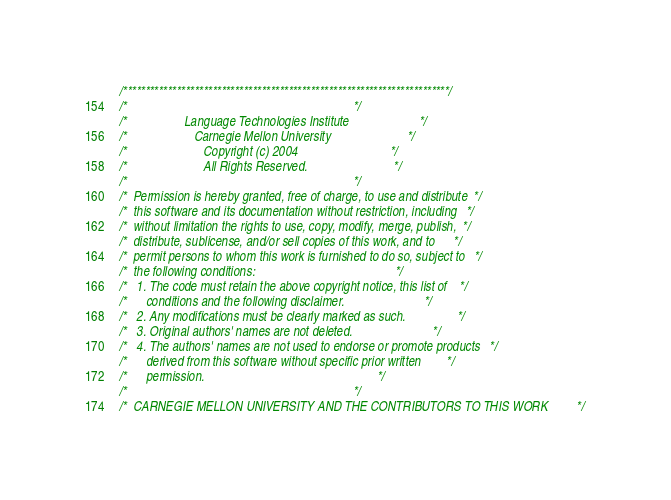Convert code to text. <code><loc_0><loc_0><loc_500><loc_500><_C_>/*************************************************************************/
/*                                                                       */
/*                  Language Technologies Institute                      */
/*                     Carnegie Mellon University                        */
/*                        Copyright (c) 2004                             */
/*                        All Rights Reserved.                           */
/*                                                                       */
/*  Permission is hereby granted, free of charge, to use and distribute  */
/*  this software and its documentation without restriction, including   */
/*  without limitation the rights to use, copy, modify, merge, publish,  */
/*  distribute, sublicense, and/or sell copies of this work, and to      */
/*  permit persons to whom this work is furnished to do so, subject to   */
/*  the following conditions:                                            */
/*   1. The code must retain the above copyright notice, this list of    */
/*      conditions and the following disclaimer.                         */
/*   2. Any modifications must be clearly marked as such.                */
/*   3. Original authors' names are not deleted.                         */
/*   4. The authors' names are not used to endorse or promote products   */
/*      derived from this software without specific prior written        */
/*      permission.                                                      */
/*                                                                       */
/*  CARNEGIE MELLON UNIVERSITY AND THE CONTRIBUTORS TO THIS WORK         */</code> 